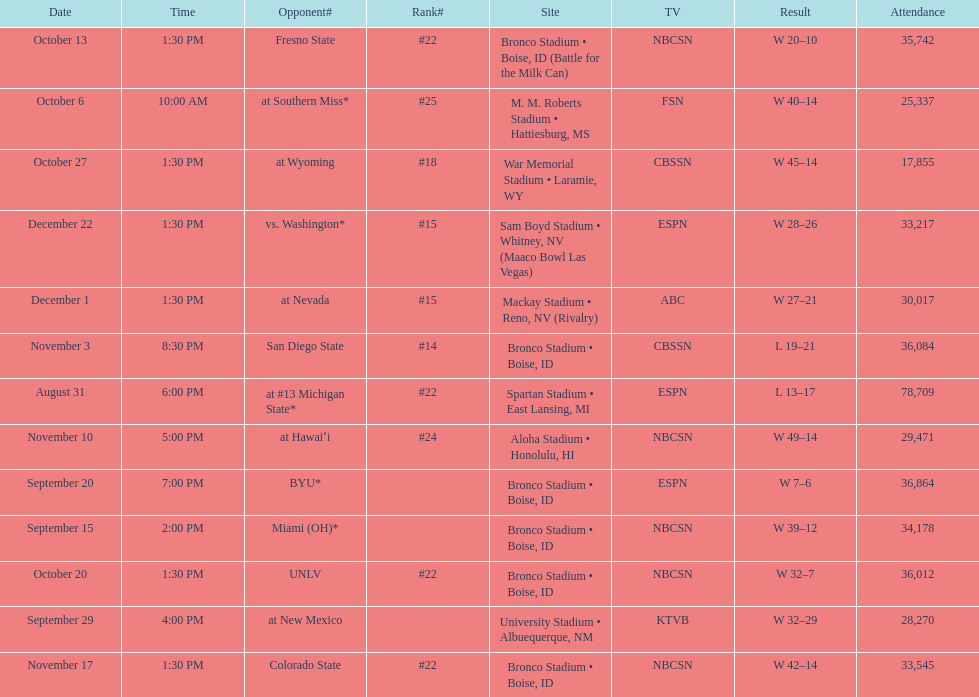Number of points scored by miami (oh) against the broncos. 12. 